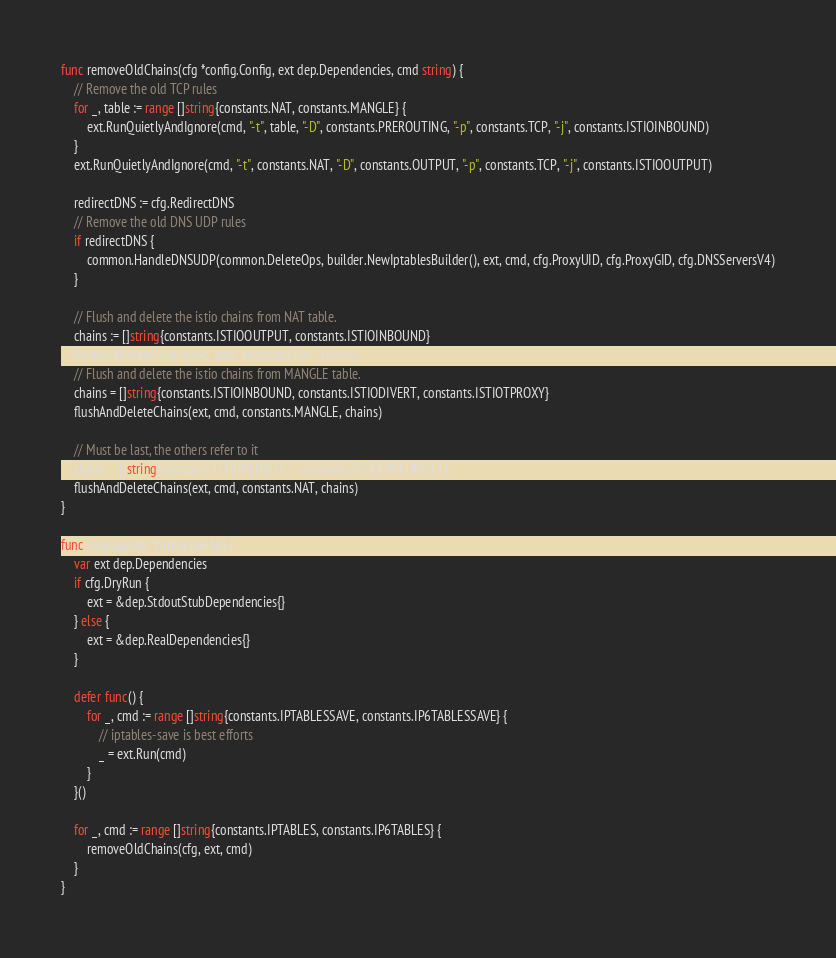Convert code to text. <code><loc_0><loc_0><loc_500><loc_500><_Go_>func removeOldChains(cfg *config.Config, ext dep.Dependencies, cmd string) {
	// Remove the old TCP rules
	for _, table := range []string{constants.NAT, constants.MANGLE} {
		ext.RunQuietlyAndIgnore(cmd, "-t", table, "-D", constants.PREROUTING, "-p", constants.TCP, "-j", constants.ISTIOINBOUND)
	}
	ext.RunQuietlyAndIgnore(cmd, "-t", constants.NAT, "-D", constants.OUTPUT, "-p", constants.TCP, "-j", constants.ISTIOOUTPUT)

	redirectDNS := cfg.RedirectDNS
	// Remove the old DNS UDP rules
	if redirectDNS {
		common.HandleDNSUDP(common.DeleteOps, builder.NewIptablesBuilder(), ext, cmd, cfg.ProxyUID, cfg.ProxyGID, cfg.DNSServersV4)
	}

	// Flush and delete the istio chains from NAT table.
	chains := []string{constants.ISTIOOUTPUT, constants.ISTIOINBOUND}
	flushAndDeleteChains(ext, cmd, constants.NAT, chains)
	// Flush and delete the istio chains from MANGLE table.
	chains = []string{constants.ISTIOINBOUND, constants.ISTIODIVERT, constants.ISTIOTPROXY}
	flushAndDeleteChains(ext, cmd, constants.MANGLE, chains)

	// Must be last, the others refer to it
	chains = []string{constants.ISTIOREDIRECT, constants.ISTIOINREDIRECT}
	flushAndDeleteChains(ext, cmd, constants.NAT, chains)
}

func cleanup(cfg *config.Config) {
	var ext dep.Dependencies
	if cfg.DryRun {
		ext = &dep.StdoutStubDependencies{}
	} else {
		ext = &dep.RealDependencies{}
	}

	defer func() {
		for _, cmd := range []string{constants.IPTABLESSAVE, constants.IP6TABLESSAVE} {
			// iptables-save is best efforts
			_ = ext.Run(cmd)
		}
	}()

	for _, cmd := range []string{constants.IPTABLES, constants.IP6TABLES} {
		removeOldChains(cfg, ext, cmd)
	}
}
</code> 